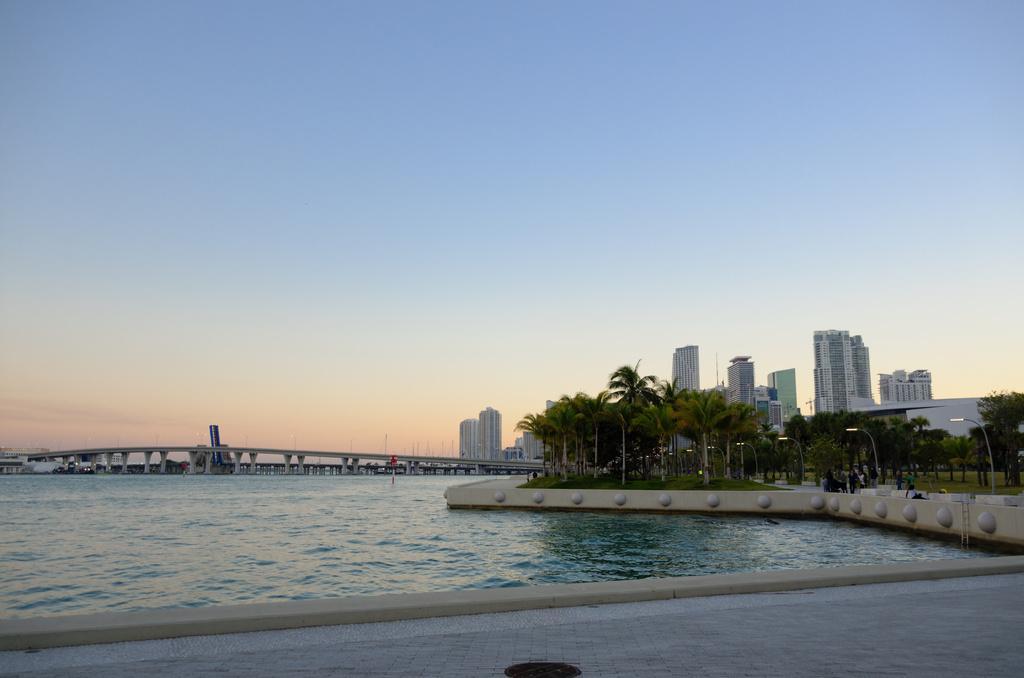Could you give a brief overview of what you see in this image? This picture is taken from outside of the city. In this image, on the right side, we can see some trees, plants, street light, building. In the middle of the image, we can see a bridge and water in a lake. In the background, we can see some buildings. At the top, we can see a sky, at the bottom, we can see water and a land. 